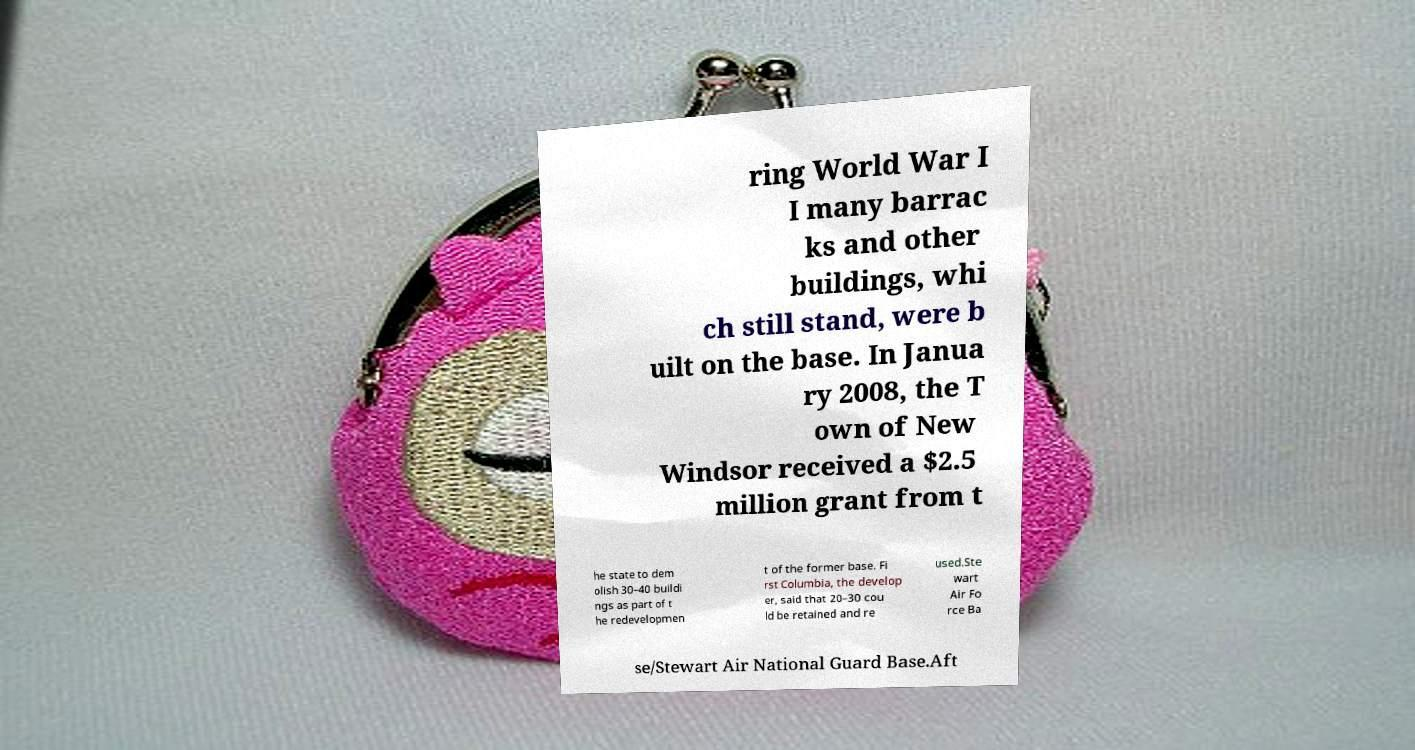What messages or text are displayed in this image? I need them in a readable, typed format. ring World War I I many barrac ks and other buildings, whi ch still stand, were b uilt on the base. In Janua ry 2008, the T own of New Windsor received a $2.5 million grant from t he state to dem olish 30–40 buildi ngs as part of t he redevelopmen t of the former base. Fi rst Columbia, the develop er, said that 20–30 cou ld be retained and re used.Ste wart Air Fo rce Ba se/Stewart Air National Guard Base.Aft 